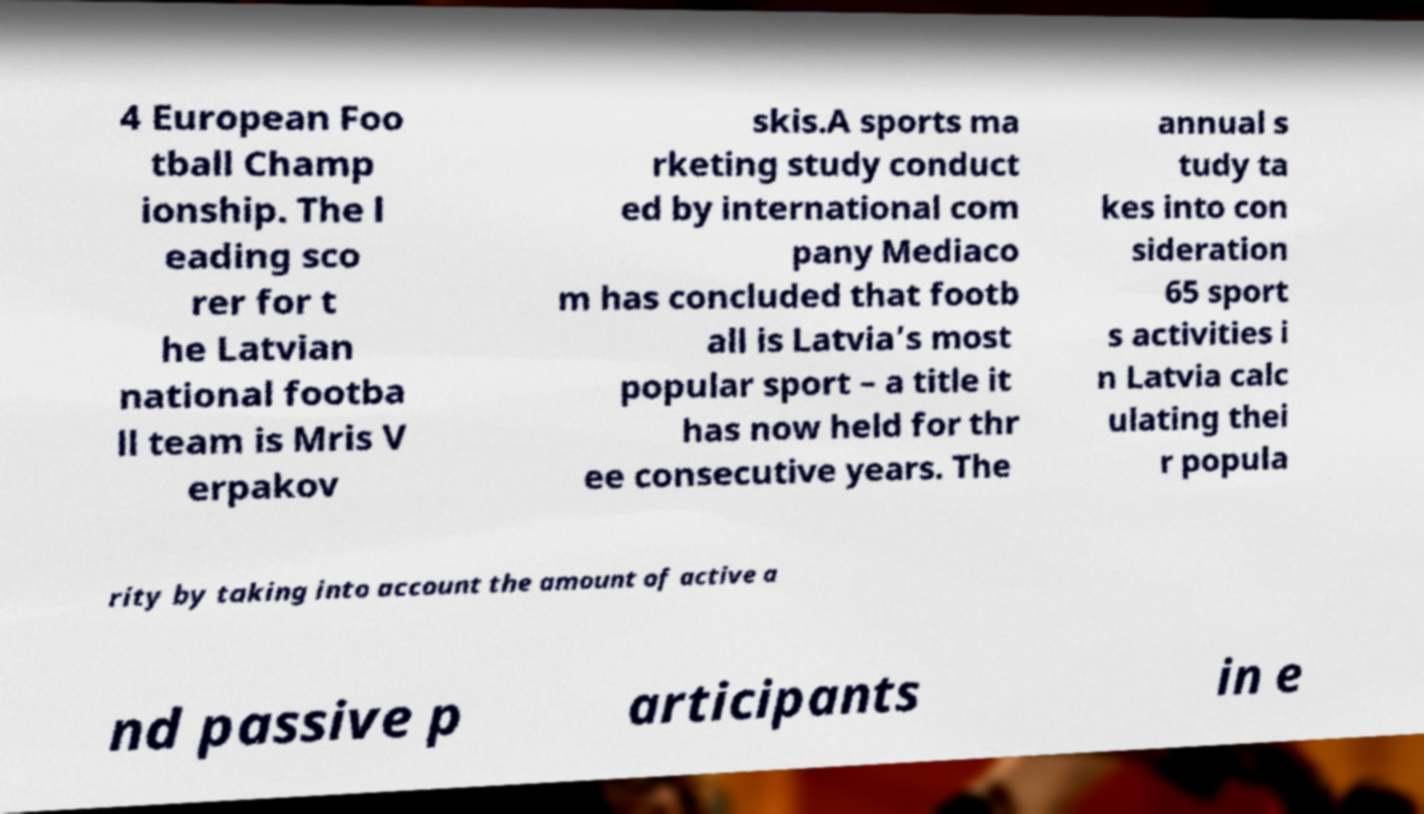Could you extract and type out the text from this image? 4 European Foo tball Champ ionship. The l eading sco rer for t he Latvian national footba ll team is Mris V erpakov skis.A sports ma rketing study conduct ed by international com pany Mediaco m has concluded that footb all is Latvia’s most popular sport – a title it has now held for thr ee consecutive years. The annual s tudy ta kes into con sideration 65 sport s activities i n Latvia calc ulating thei r popula rity by taking into account the amount of active a nd passive p articipants in e 